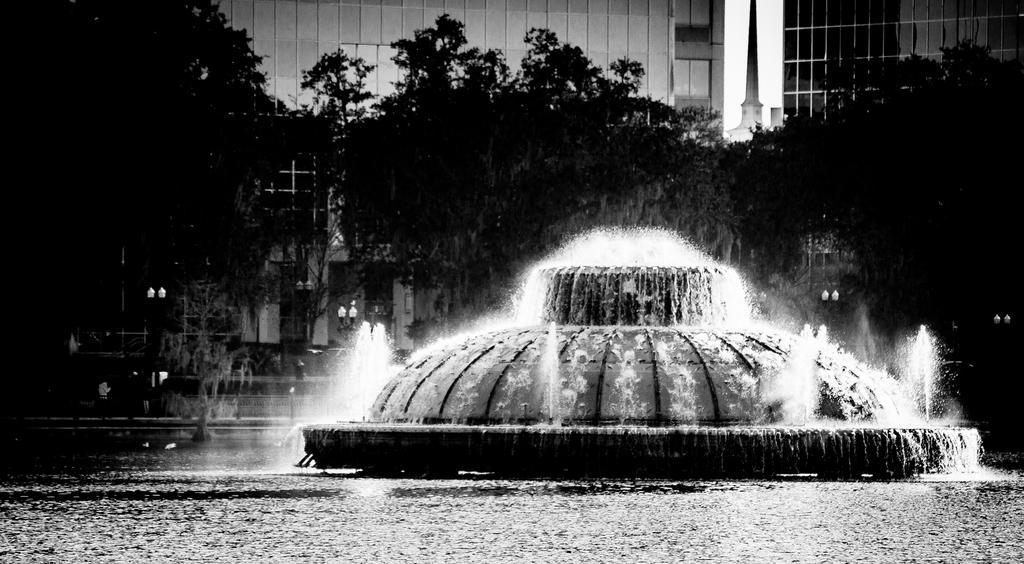Can you describe this image briefly? These are the waterfalls in the middle of an image. There are trees at here, in the long back side these are the buildings. 